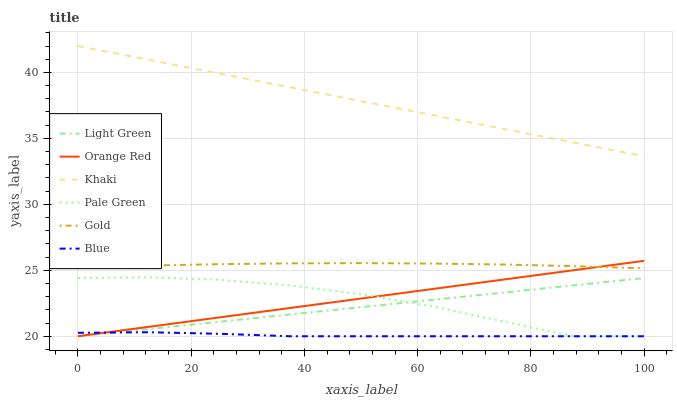Does Blue have the minimum area under the curve?
Answer yes or no. Yes. Does Khaki have the maximum area under the curve?
Answer yes or no. Yes. Does Gold have the minimum area under the curve?
Answer yes or no. No. Does Gold have the maximum area under the curve?
Answer yes or no. No. Is Orange Red the smoothest?
Answer yes or no. Yes. Is Pale Green the roughest?
Answer yes or no. Yes. Is Khaki the smoothest?
Answer yes or no. No. Is Khaki the roughest?
Answer yes or no. No. Does Gold have the lowest value?
Answer yes or no. No. Does Gold have the highest value?
Answer yes or no. No. Is Gold less than Khaki?
Answer yes or no. Yes. Is Gold greater than Light Green?
Answer yes or no. Yes. Does Gold intersect Khaki?
Answer yes or no. No. 